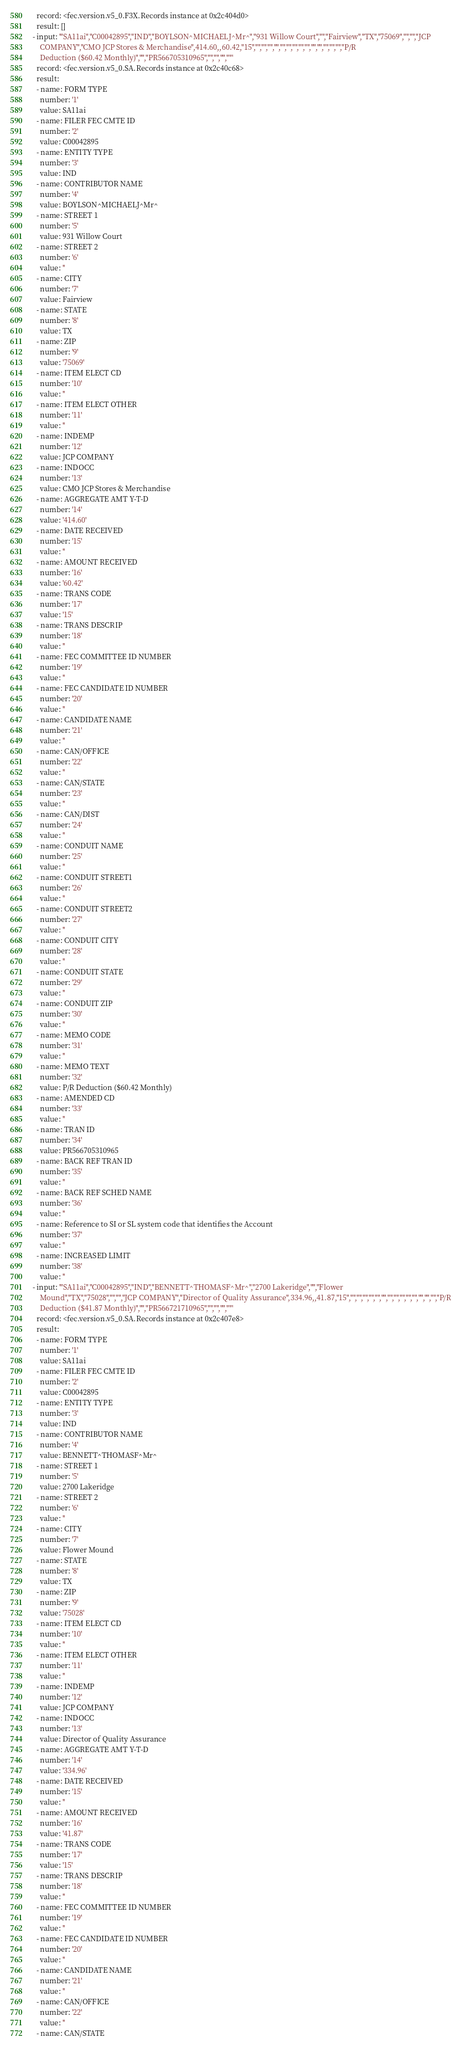<code> <loc_0><loc_0><loc_500><loc_500><_YAML_>  record: <fec.version.v5_0.F3X.Records instance at 0x2c404d0>
  result: []
- input: '"SA11ai","C00042895","IND","BOYLSON^MICHAELJ^Mr^","931 Willow Court","","Fairview","TX","75069","","","JCP
    COMPANY","CMO JCP Stores & Merchandise",414.60,,60.42,"15","","","","","","","","","","","","","","","P/R
    Deduction ($60.42 Monthly)","","PR566705310965","","","",""'
  record: <fec.version.v5_0.SA.Records instance at 0x2c40c68>
  result:
  - name: FORM TYPE
    number: '1'
    value: SA11ai
  - name: FILER FEC CMTE ID
    number: '2'
    value: C00042895
  - name: ENTITY TYPE
    number: '3'
    value: IND
  - name: CONTRIBUTOR NAME
    number: '4'
    value: BOYLSON^MICHAELJ^Mr^
  - name: STREET 1
    number: '5'
    value: 931 Willow Court
  - name: STREET 2
    number: '6'
    value: ''
  - name: CITY
    number: '7'
    value: Fairview
  - name: STATE
    number: '8'
    value: TX
  - name: ZIP
    number: '9'
    value: '75069'
  - name: ITEM ELECT CD
    number: '10'
    value: ''
  - name: ITEM ELECT OTHER
    number: '11'
    value: ''
  - name: INDEMP
    number: '12'
    value: JCP COMPANY
  - name: INDOCC
    number: '13'
    value: CMO JCP Stores & Merchandise
  - name: AGGREGATE AMT Y-T-D
    number: '14'
    value: '414.60'
  - name: DATE RECEIVED
    number: '15'
    value: ''
  - name: AMOUNT RECEIVED
    number: '16'
    value: '60.42'
  - name: TRANS CODE
    number: '17'
    value: '15'
  - name: TRANS DESCRIP
    number: '18'
    value: ''
  - name: FEC COMMITTEE ID NUMBER
    number: '19'
    value: ''
  - name: FEC CANDIDATE ID NUMBER
    number: '20'
    value: ''
  - name: CANDIDATE NAME
    number: '21'
    value: ''
  - name: CAN/OFFICE
    number: '22'
    value: ''
  - name: CAN/STATE
    number: '23'
    value: ''
  - name: CAN/DIST
    number: '24'
    value: ''
  - name: CONDUIT NAME
    number: '25'
    value: ''
  - name: CONDUIT STREET1
    number: '26'
    value: ''
  - name: CONDUIT STREET2
    number: '27'
    value: ''
  - name: CONDUIT CITY
    number: '28'
    value: ''
  - name: CONDUIT STATE
    number: '29'
    value: ''
  - name: CONDUIT ZIP
    number: '30'
    value: ''
  - name: MEMO CODE
    number: '31'
    value: ''
  - name: MEMO TEXT
    number: '32'
    value: P/R Deduction ($60.42 Monthly)
  - name: AMENDED CD
    number: '33'
    value: ''
  - name: TRAN ID
    number: '34'
    value: PR566705310965
  - name: BACK REF TRAN ID
    number: '35'
    value: ''
  - name: BACK REF SCHED NAME
    number: '36'
    value: ''
  - name: Reference to SI or SL system code that identifies the Account
    number: '37'
    value: ''
  - name: INCREASED LIMIT
    number: '38'
    value: ''
- input: '"SA11ai","C00042895","IND","BENNETT^THOMASF^Mr^","2700 Lakeridge","","Flower
    Mound","TX","75028","","","JCP COMPANY","Director of Quality Assurance",334.96,,41.87,"15","","","","","","","","","","","","","","","P/R
    Deduction ($41.87 Monthly)","","PR566721710965","","","",""'
  record: <fec.version.v5_0.SA.Records instance at 0x2c407e8>
  result:
  - name: FORM TYPE
    number: '1'
    value: SA11ai
  - name: FILER FEC CMTE ID
    number: '2'
    value: C00042895
  - name: ENTITY TYPE
    number: '3'
    value: IND
  - name: CONTRIBUTOR NAME
    number: '4'
    value: BENNETT^THOMASF^Mr^
  - name: STREET 1
    number: '5'
    value: 2700 Lakeridge
  - name: STREET 2
    number: '6'
    value: ''
  - name: CITY
    number: '7'
    value: Flower Mound
  - name: STATE
    number: '8'
    value: TX
  - name: ZIP
    number: '9'
    value: '75028'
  - name: ITEM ELECT CD
    number: '10'
    value: ''
  - name: ITEM ELECT OTHER
    number: '11'
    value: ''
  - name: INDEMP
    number: '12'
    value: JCP COMPANY
  - name: INDOCC
    number: '13'
    value: Director of Quality Assurance
  - name: AGGREGATE AMT Y-T-D
    number: '14'
    value: '334.96'
  - name: DATE RECEIVED
    number: '15'
    value: ''
  - name: AMOUNT RECEIVED
    number: '16'
    value: '41.87'
  - name: TRANS CODE
    number: '17'
    value: '15'
  - name: TRANS DESCRIP
    number: '18'
    value: ''
  - name: FEC COMMITTEE ID NUMBER
    number: '19'
    value: ''
  - name: FEC CANDIDATE ID NUMBER
    number: '20'
    value: ''
  - name: CANDIDATE NAME
    number: '21'
    value: ''
  - name: CAN/OFFICE
    number: '22'
    value: ''
  - name: CAN/STATE</code> 